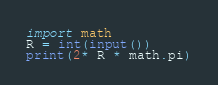<code> <loc_0><loc_0><loc_500><loc_500><_Python_>import math
R = int(input())
print(2* R * math.pi)
</code> 